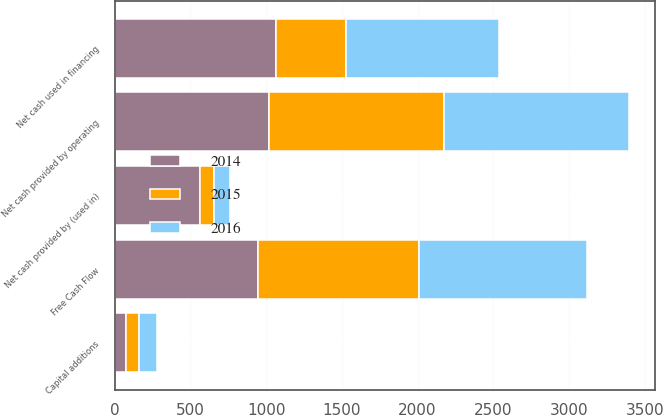Convert chart to OTSL. <chart><loc_0><loc_0><loc_500><loc_500><stacked_bar_chart><ecel><fcel>Net cash provided by operating<fcel>Capital additions<fcel>Free Cash Flow<fcel>Net cash provided by (used in)<fcel>Net cash used in financing<nl><fcel>2016<fcel>1226.1<fcel>115.2<fcel>1110.9<fcel>102<fcel>1009.8<nl><fcel>2015<fcel>1153.6<fcel>89<fcel>1064.6<fcel>92<fcel>461<nl><fcel>2014<fcel>1018.6<fcel>74.6<fcel>944<fcel>564.9<fcel>1064.5<nl></chart> 